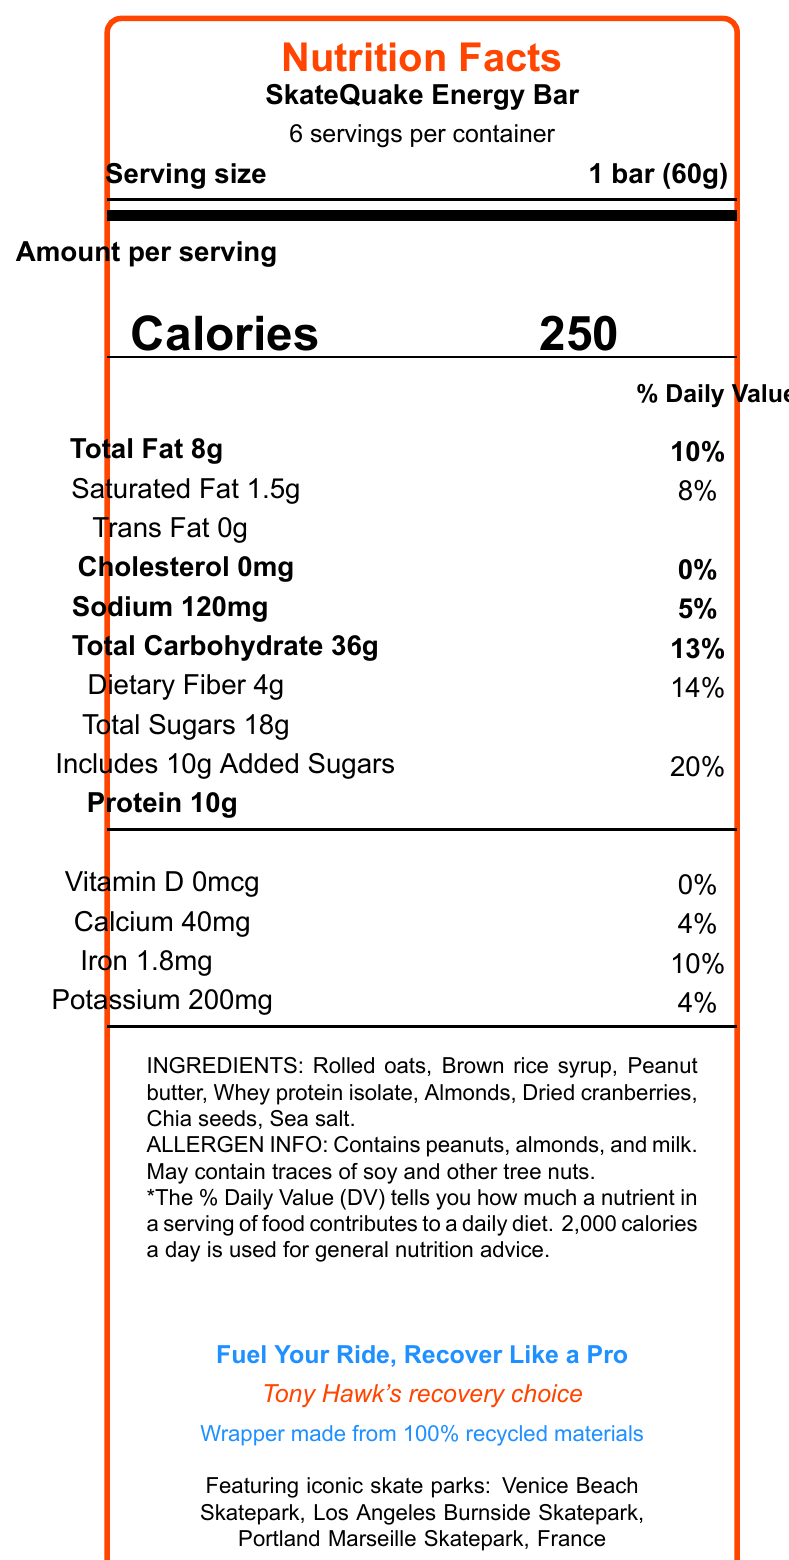what is the serving size of the SkateQuake Energy Bar? The serving size is mentioned in the document as "Serving size: 1 bar (60g)".
Answer: 1 bar (60g) how many calories are in a single serving of the SkateQuake Energy Bar? The document states "Calories 250" for the amount per serving.
Answer: 250 calories what is the amount of protein in one bar of the SkateQuake Energy Bar? The document lists "Protein 10g" as the amount per serving.
Answer: 10 grams which famous skate parks are featured on the packaging? The document specifies the featured skate parks under the package design section.
Answer: Venice Beach Skatepark, Los Angeles; Burnside Skatepark, Portland; Marseille Skatepark, France what is the tagline of the SkateQuake Energy Bar? The tagline is shown in the document near the bottom and is "Fuel Your Ride, Recover Like a Pro."
Answer: Fuel Your Ride, Recover Like a Pro how much saturated fat is in one serving? A. 0g B. 1g C. 1.5g D. 2g The document lists "Saturated Fat 1.5g" under the total fat section.
Answer: C what is the daily value percentage for added sugars in the SkateQuake Energy Bar? I. 10% II. 20% III. 30% IV. 40% The document shows "Includes 10g Added Sugars, 20%" which means the daily value percentage is 20%.
Answer: II does the SkateQuake Energy Bar contain any cholesterol? The document states "Cholesterol 0mg, 0%" indicating there is no cholesterol in the energy bar.
Answer: No what are the primary ingredients in the SkateQuake Energy Bar? The ingredients section lists all the primary components in the energy bar.
Answer: Rolled oats, Brown rice syrup, Peanut butter, Whey protein isolate, Almonds, Dried cranberries, Chia seeds, Sea salt which professional skater endorses the SkateQuake Energy Bar? The document mentions "Tony Hawk's recovery choice" near the bottom, indicating his endorsement.
Answer: Tony Hawk summarize the main information in the SkateQuake Energy Bar nutritional label. This summarizes the main components and features of the energy bar as presented in the document.
Answer: The SkateQuake Energy Bar offers 250 calories per bar (60g) with a good balance of nutrients including 8g of total fat, 10g of protein, and 36g of total carbohydrates (including 4g of dietary fiber and 18g of total sugars). It contains no cholesterol, low sodium (120mg), and provides 10% of the daily value for iron. Primary ingredients include rolled oats, peanut butter, whey protein isolate, and almonds. The bar is endorsed by Tony Hawk and features designs of famous skate parks. The packaging is eco-friendly, made from 100% recycled materials. how much potassium is in one serving? The document specifies "Potassium 200mg" under the nutrient details.
Answer: 200mg is there any vitamin D in the SkateQuake Energy Bar? The document shows "Vitamin D 0mcg, 0%" indicating there is no vitamin D.
Answer: No is the wrapper of the SkateQuake Energy Bar environmentally friendly? The document mentions that the wrapper is made from 100% recycled materials, indicating its eco-friendliness.
Answer: Yes does the SkateQuake Energy Bar contain soy? The document states it "May contain traces of soy," but this does not confirm the presence of soy in every bar.
Answer: Not enough information 